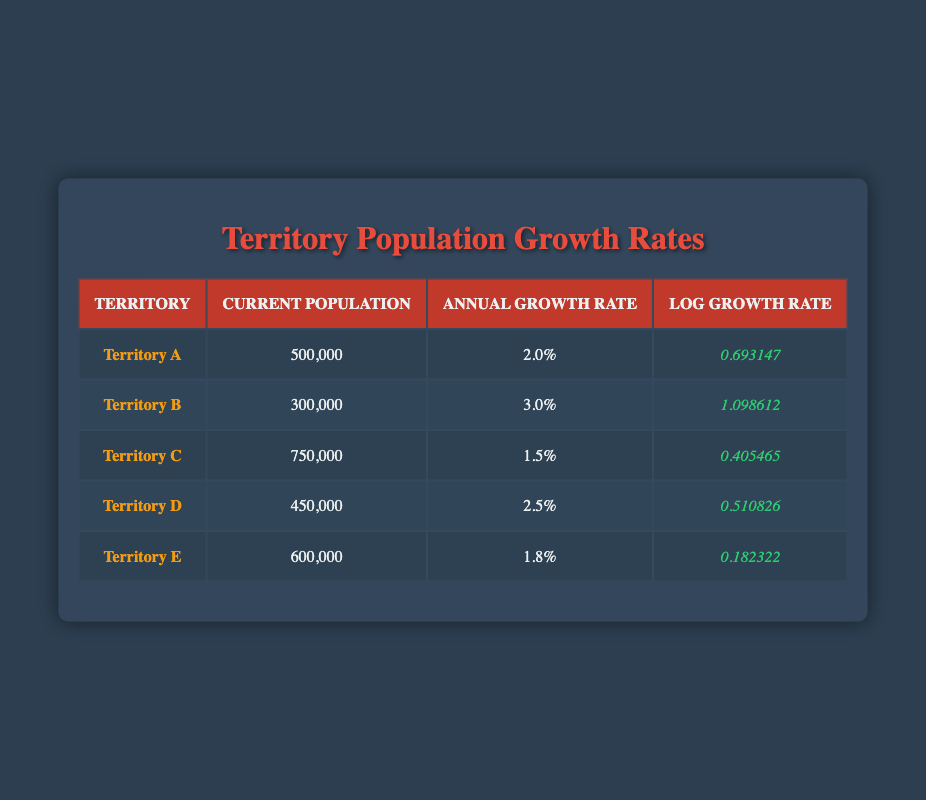What is the current population of Territory B? The table shows that the current population for Territory B is listed in the second row under the "Current Population" column. The value is 300,000.
Answer: 300,000 What is the annual growth rate of Territory D? The annual growth rate for Territory D is directly available in the third column for the respective territory in the table. It is noted as 2.5%.
Answer: 2.5% Which territory has the highest log growth rate? To find the highest log growth rate, we compare all the values in the "Log Growth Rate" column. The values are 0.693147 (Territory A), 1.098612 (Territory B), 0.405465 (Territory C), 0.510826 (Territory D), and 0.182322 (Territory E). The highest value is 1.098612 for Territory B.
Answer: Territory B What is the average current population of all territories? To find the average, sum the current population values: 500,000 + 300,000 + 750,000 + 450,000 + 600,000 = 2,600,000. There are 5 territories, so the average is 2,600,000 / 5 = 520,000.
Answer: 520,000 Is the growth rate of Territory E greater than that of Territory C? The annual growth rates are 1.8% for Territory E and 1.5% for Territory C. Since 1.8% is greater than 1.5%, the statement is true.
Answer: Yes How many territories have a growth rate of 2% or higher? The territories with growth rates of 2% or higher are analyzed from their respective annual growth rates: Territory A (2%), Territory B (3%), Territory D (2.5%). Territory C (1.5%) and Territory E (1.8%) do not meet this criterion. This gives us a total of 3 territories.
Answer: 3 What is the total log growth rate of all territories combined? To obtain the total log growth rate, we need to add all the log growth rates from the table: 0.693147 + 1.098612 + 0.405465 + 0.510826 + 0.182322 = 3.890372.
Answer: 3.890372 Which territory has the lowest current population? By reviewing the "Current Population" column, we find the values: 500,000 for Territory A, 300,000 for Territory B, 750,000 for Territory C, 450,000 for Territory D, and 600,000 for Territory E. The smallest value is 300,000 for Territory B.
Answer: Territory B Is it true that Territory D has a lower growth rate than Territory A? The growth rate for Territory D is 2.5% and for Territory A is 2.0%. Since 2.5% is greater than 2.0%, the statement is false.
Answer: No 